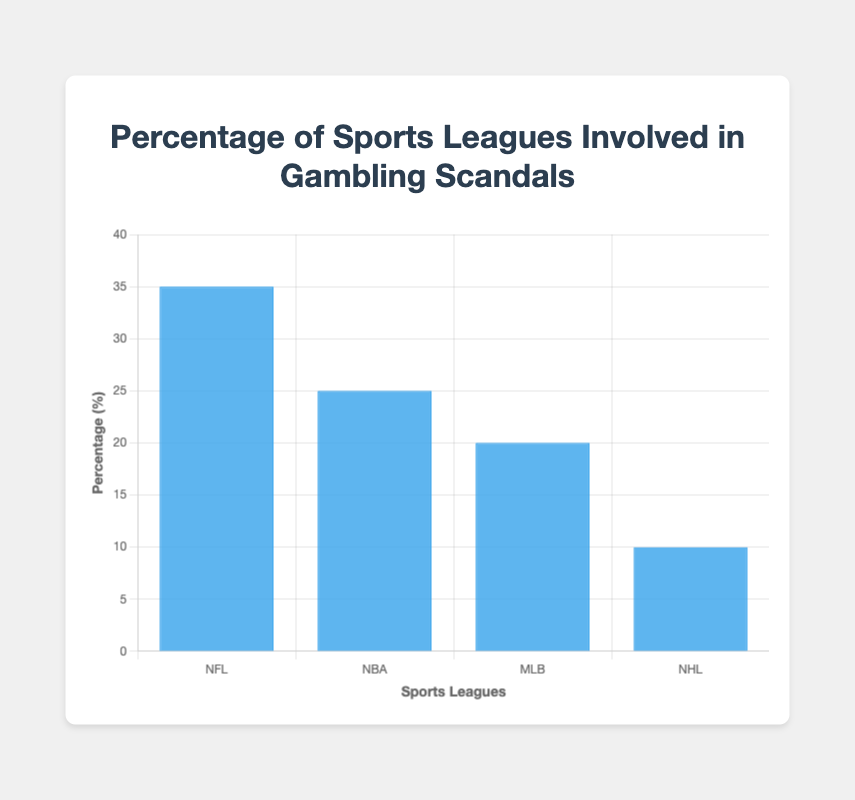Which sports league has the highest percentage involved in gambling scandals? The bar chart shows that the NFL has the highest percentage of 35%. By visually inspecting the heights of the bars, we can see that the NFL's bar is the tallest.
Answer: NFL Which sports league has the lowest percentage involved in gambling scandals? The bar chart shows that the NHL has the lowest percentage of 10%. By visually inspecting the heights of the bars, we can see that the NHL's bar is the shortest.
Answer: NHL What is the total percentage of gambling scandals involving the NFL and NBA combined? The percentage of gambling scandals for the NFL is 35% and for the NBA is 25%. Adding these together gives 35 + 25 = 60%.
Answer: 60% How much higher is the percentage of gambling scandals in the NFL compared to the MLB? The percentage for the NFL is 35% and for the MLB is 20%. Subtracting these values gives 35 - 20 = 15%.
Answer: 15% What is the average percentage of gambling scandals across all four leagues? The percentages are 35% (NFL), 25% (NBA), 20% (MLB), and 10% (NHL). Adding these gives a total of 35 + 25 + 20 + 10 = 90%. Dividing this by the number of leagues (4) gives an average of 90 / 4 = 22.5%.
Answer: 22.5% Compare the percentage of gambling scandals in the NBA and NHL. Which is higher and by how much? The NBA has 25% and the NHL has 10%. The NBA's percentage is higher by subtracting the two values, 25 - 10 = 15%.
Answer: NBA, 15% Is the sum of the percentages of MLB and NHL equal to the percentage of the NFL? The percentage for MLB is 20% and for NHL is 10%. Adding these together gives 20 + 10 = 30%, which is not equal to the NFL's percentage of 35%.
Answer: No Which league's percentage of gambling scandals is exactly halfway between the highest and lowest percentages? The highest percentage is from the NFL at 35%, and the lowest is from the NHL at 10%. The halfway point is (35 + 10) / 2 = 22.5%. The MLB at 20% is the closest to this halfway point.
Answer: MLB 